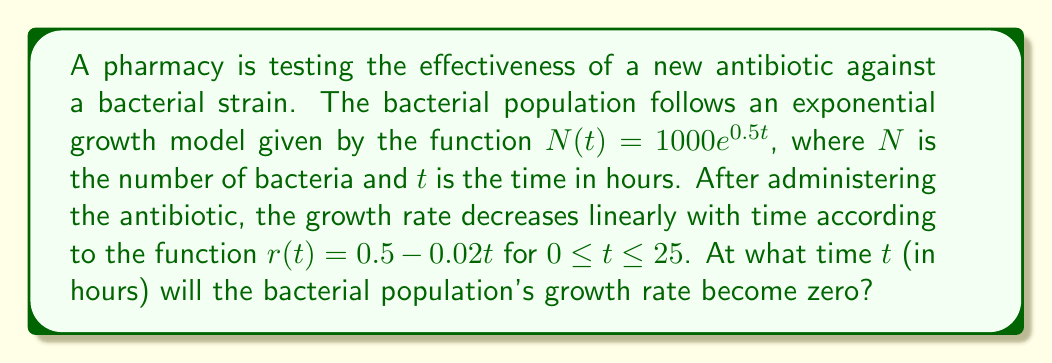Can you answer this question? To solve this problem, we need to follow these steps:

1) The initial growth rate is given by the coefficient of $t$ in the exponent of the original function: $0.5$ per hour.

2) The new growth rate function after administering the antibiotic is:

   $r(t) = 0.5 - 0.02t$

3) We need to find when this growth rate becomes zero. Mathematically, we need to solve:

   $0.5 - 0.02t = 0$

4) Solving this equation:
   
   $0.5 = 0.02t$
   $t = 0.5 / 0.02 = 25$

5) We need to check if this solution falls within the given domain of $0 \leq t \leq 25$. It does, as $t = 25$ is exactly at the upper bound of the domain.

Therefore, the bacterial population's growth rate will become zero after 25 hours of administering the antibiotic.
Answer: 25 hours 